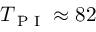<formula> <loc_0><loc_0><loc_500><loc_500>T _ { P I } \approx 8 2</formula> 